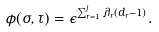Convert formula to latex. <formula><loc_0><loc_0><loc_500><loc_500>\phi ( \sigma , \tau ) = \epsilon ^ { \sum _ { r = 1 } ^ { j } \lambda _ { r } ( d _ { r } - 1 ) } .</formula> 